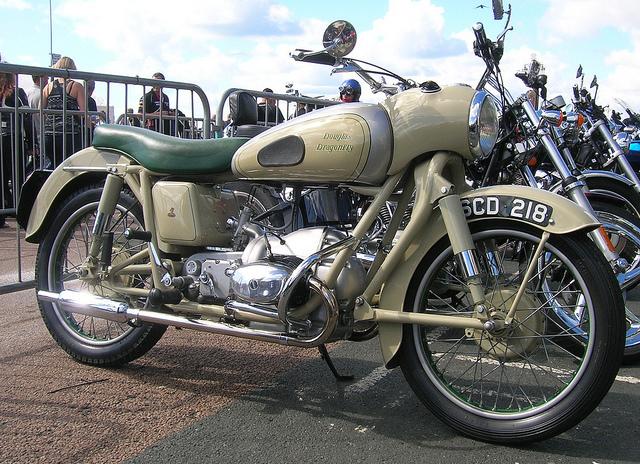What is the id number on the motorcycle?
Short answer required. 218. Is the motorcycle's kickstand up or down?
Keep it brief. Down. Is the bike old?
Quick response, please. Yes. 